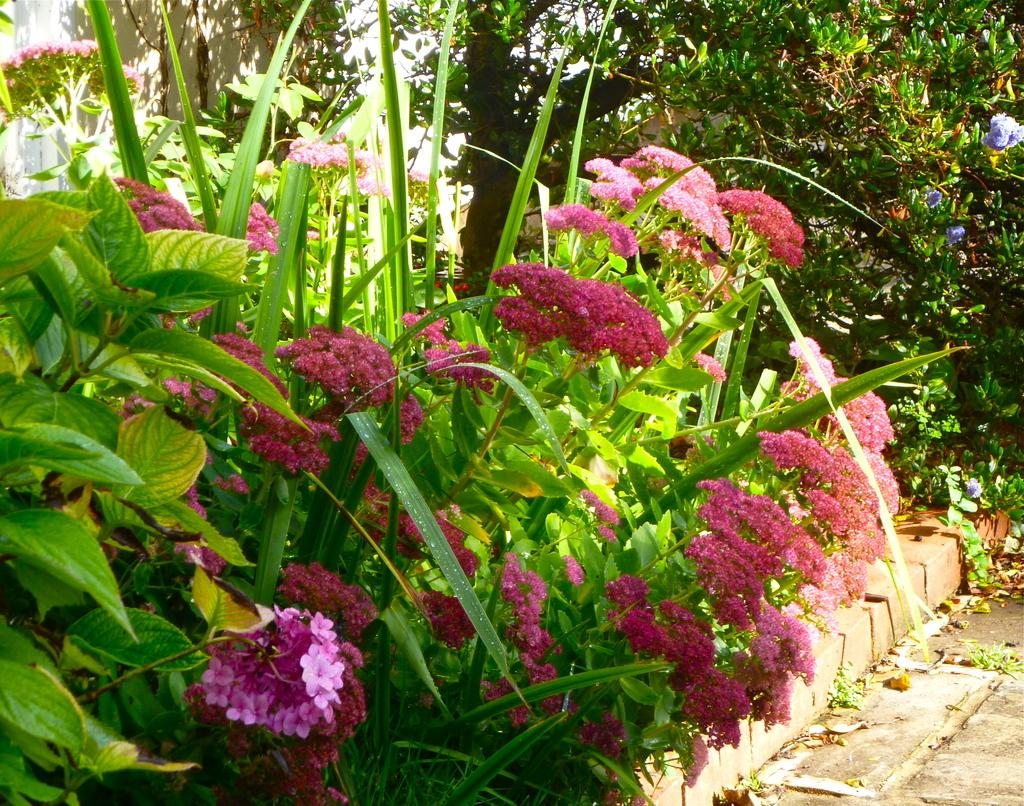What type of living organisms can be seen in the image? The image contains plants with flowers. What can be seen in the background of the image? There are trees in the background of the image. What is located on the left side of the image? There is a wall on the left side of the image. What is at the bottom of the image? There is a road at the bottom of the image. What type of dress is the tree wearing in the image? There is no dress present in the image, as trees are not capable of wearing clothing. 